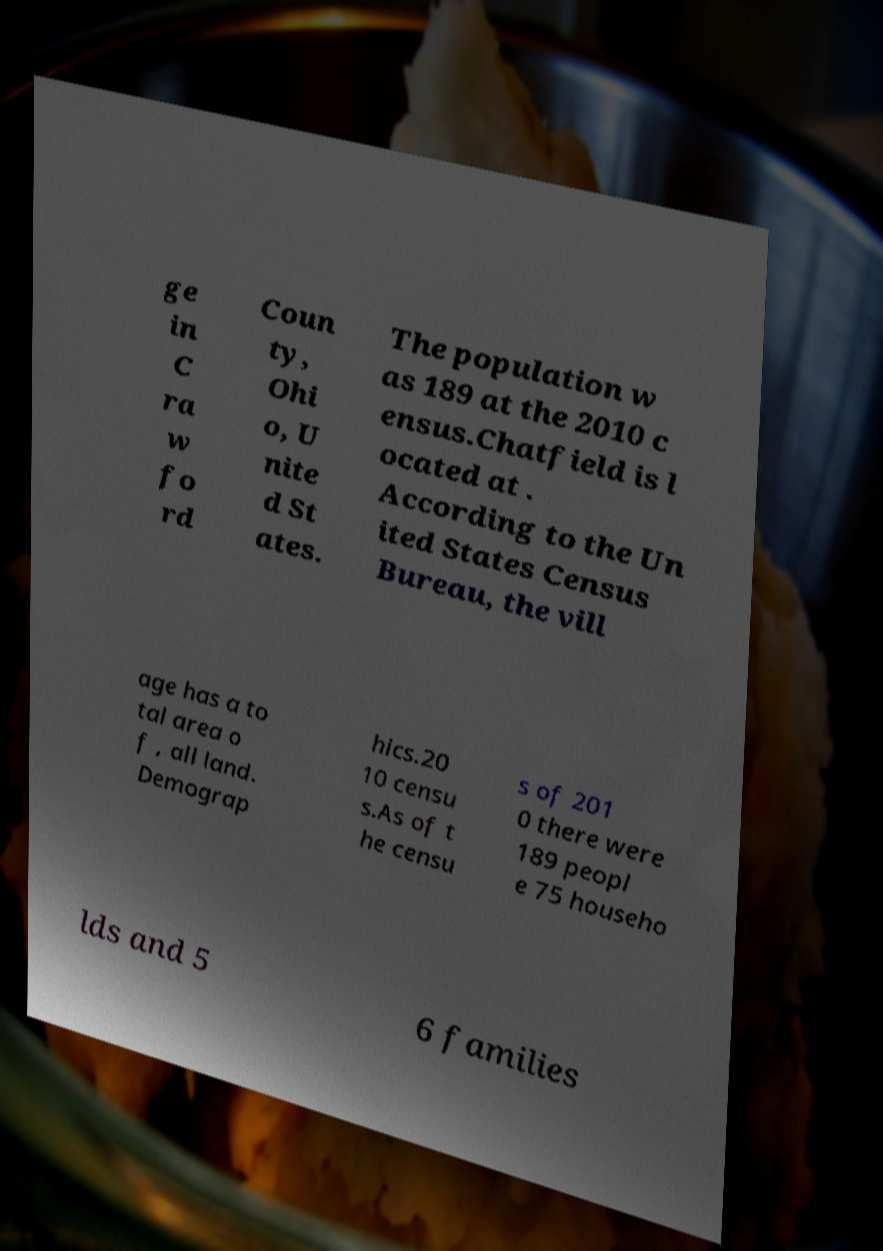I need the written content from this picture converted into text. Can you do that? ge in C ra w fo rd Coun ty, Ohi o, U nite d St ates. The population w as 189 at the 2010 c ensus.Chatfield is l ocated at . According to the Un ited States Census Bureau, the vill age has a to tal area o f , all land. Demograp hics.20 10 censu s.As of t he censu s of 201 0 there were 189 peopl e 75 househo lds and 5 6 families 